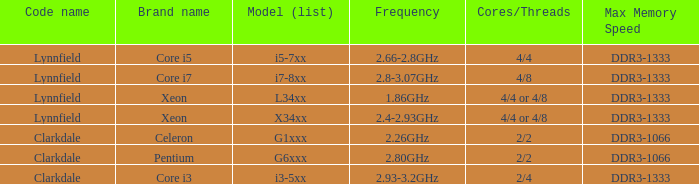What manufacturer produces model i7-8xx? Core i7. 